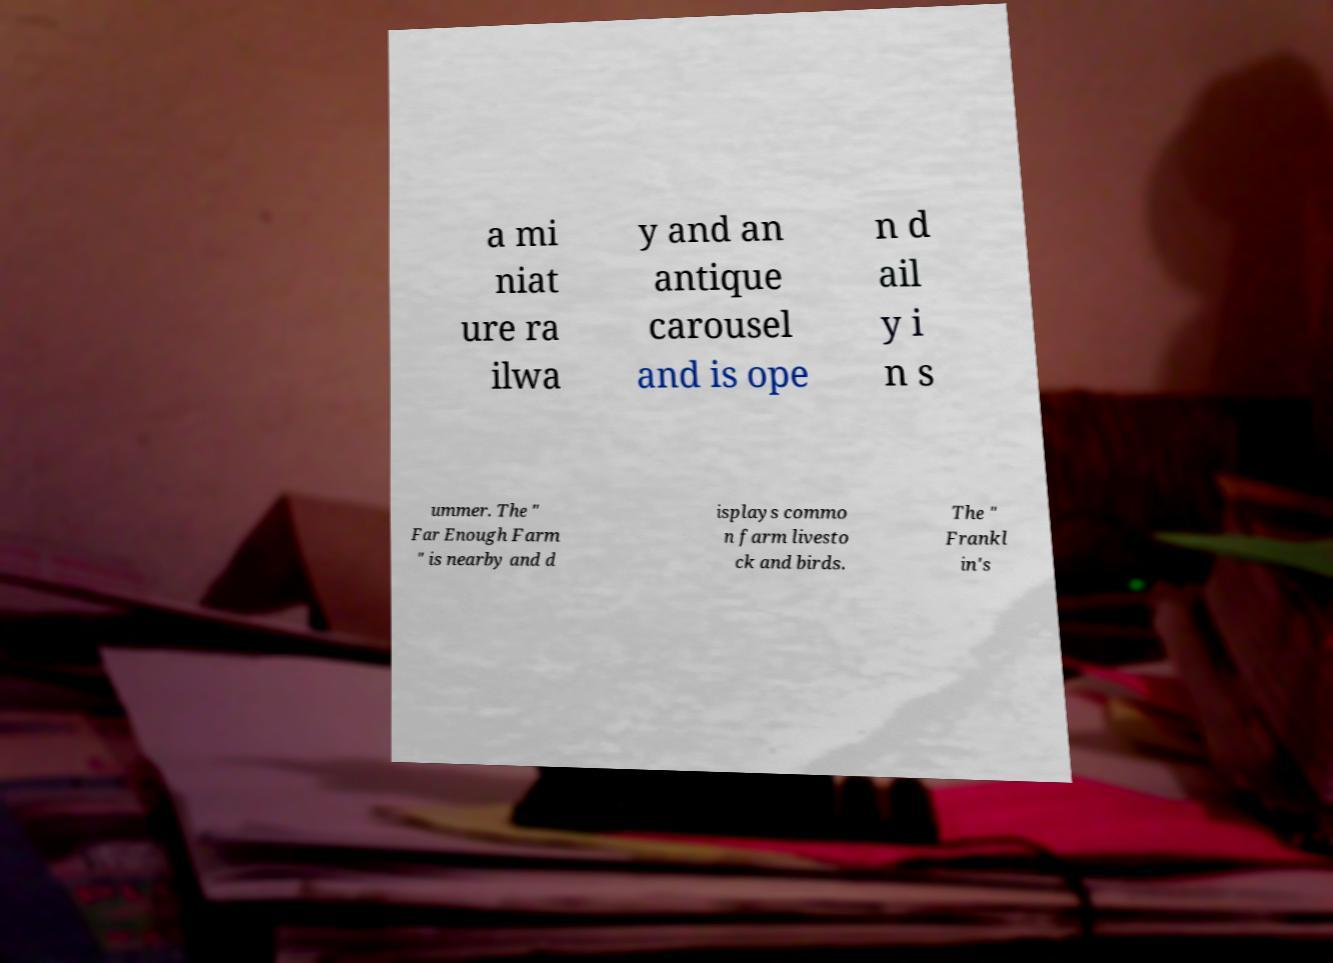Please identify and transcribe the text found in this image. a mi niat ure ra ilwa y and an antique carousel and is ope n d ail y i n s ummer. The " Far Enough Farm " is nearby and d isplays commo n farm livesto ck and birds. The " Frankl in's 